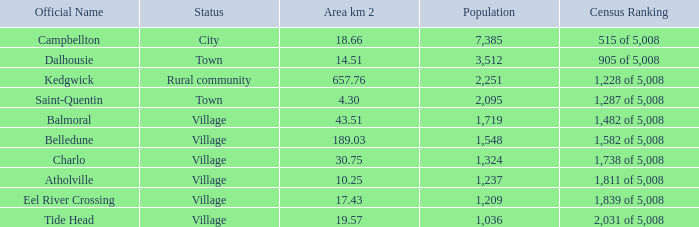I'm looking to parse the entire table for insights. Could you assist me with that? {'header': ['Official Name', 'Status', 'Area km 2', 'Population', 'Census Ranking'], 'rows': [['Campbellton', 'City', '18.66', '7,385', '515 of 5,008'], ['Dalhousie', 'Town', '14.51', '3,512', '905 of 5,008'], ['Kedgwick', 'Rural community', '657.76', '2,251', '1,228 of 5,008'], ['Saint-Quentin', 'Town', '4.30', '2,095', '1,287 of 5,008'], ['Balmoral', 'Village', '43.51', '1,719', '1,482 of 5,008'], ['Belledune', 'Village', '189.03', '1,548', '1,582 of 5,008'], ['Charlo', 'Village', '30.75', '1,324', '1,738 of 5,008'], ['Atholville', 'Village', '10.25', '1,237', '1,811 of 5,008'], ['Eel River Crossing', 'Village', '17.43', '1,209', '1,839 of 5,008'], ['Tide Head', 'Village', '19.57', '1,036', '2,031 of 5,008']]} In a rural community setting, what is the smallest area measured in square kilometers? 657.76. 